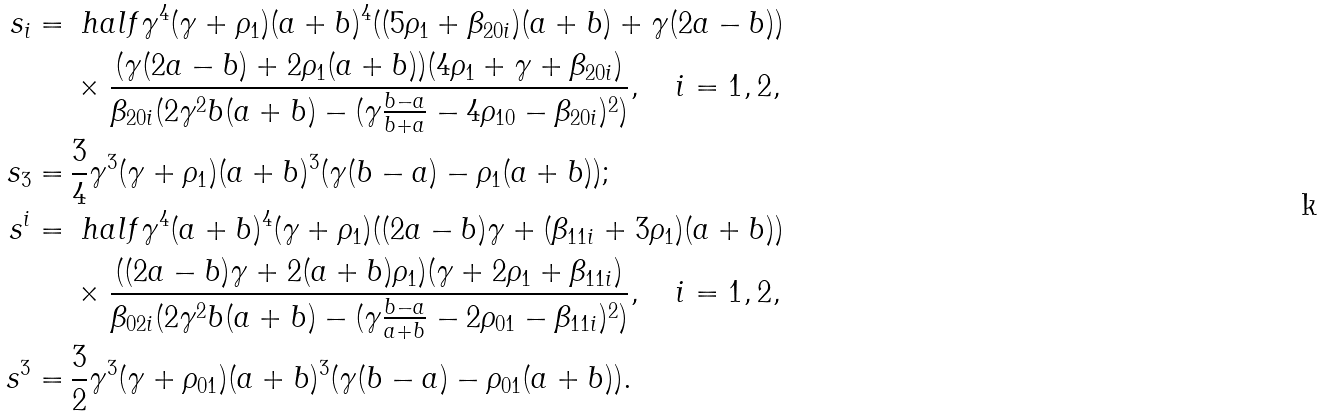<formula> <loc_0><loc_0><loc_500><loc_500>s _ { i } = \, & \ h a l f \gamma ^ { 4 } ( \gamma + \rho _ { 1 } ) ( a + b ) ^ { 4 } ( ( 5 \rho _ { 1 } + \beta _ { 2 0 i } ) ( a + b ) + \gamma ( 2 a - b ) ) \\ & \times \frac { ( \gamma ( 2 a - b ) + 2 \rho _ { 1 } ( a + b ) ) ( 4 \rho _ { 1 } + \gamma + \beta _ { 2 0 i } ) } { \beta _ { 2 0 i } ( 2 \gamma ^ { 2 } b ( a + b ) - ( \gamma \frac { b - a } { b + a } - 4 \rho _ { 1 0 } - \beta _ { 2 0 i } ) ^ { 2 } ) } , \quad i = 1 , 2 , \\ s _ { 3 } = \, & \frac { 3 } { 4 } \gamma ^ { 3 } ( \gamma + \rho _ { 1 } ) ( a + b ) ^ { 3 } ( \gamma ( b - a ) - \rho _ { 1 } ( a + b ) ) ; \\ s ^ { i } = \, & \ h a l f \gamma ^ { 4 } ( a + b ) ^ { 4 } ( \gamma + \rho _ { 1 } ) ( ( 2 a - b ) \gamma + ( \beta _ { 1 1 i } + 3 \rho _ { 1 } ) ( a + b ) ) \\ & \times \frac { ( ( 2 a - b ) \gamma + 2 ( a + b ) \rho _ { 1 } ) ( \gamma + 2 \rho _ { 1 } + \beta _ { 1 1 i } ) } { \beta _ { 0 2 i } ( 2 \gamma ^ { 2 } b ( a + b ) - ( \gamma \frac { b - a } { a + b } - 2 \rho _ { 0 1 } - \beta _ { 1 1 i } ) ^ { 2 } ) } , \quad i = 1 , 2 , \\ s ^ { 3 } = \, & \frac { 3 } { 2 } \gamma ^ { 3 } ( \gamma + \rho _ { 0 1 } ) ( a + b ) ^ { 3 } ( \gamma ( b - a ) - \rho _ { 0 1 } ( a + b ) ) .</formula> 